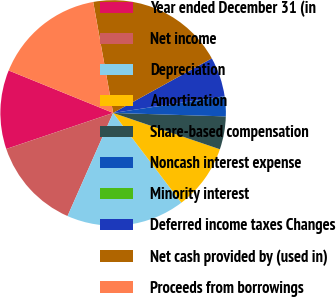<chart> <loc_0><loc_0><loc_500><loc_500><pie_chart><fcel>Year ended December 31 (in<fcel>Net income<fcel>Depreciation<fcel>Amortization<fcel>Share-based compensation<fcel>Noncash interest expense<fcel>Minority interest<fcel>Deferred income taxes Changes<fcel>Net cash provided by (used in)<fcel>Proceeds from borrowings<nl><fcel>11.32%<fcel>13.2%<fcel>16.97%<fcel>9.44%<fcel>4.73%<fcel>2.84%<fcel>0.02%<fcel>5.67%<fcel>19.79%<fcel>16.03%<nl></chart> 